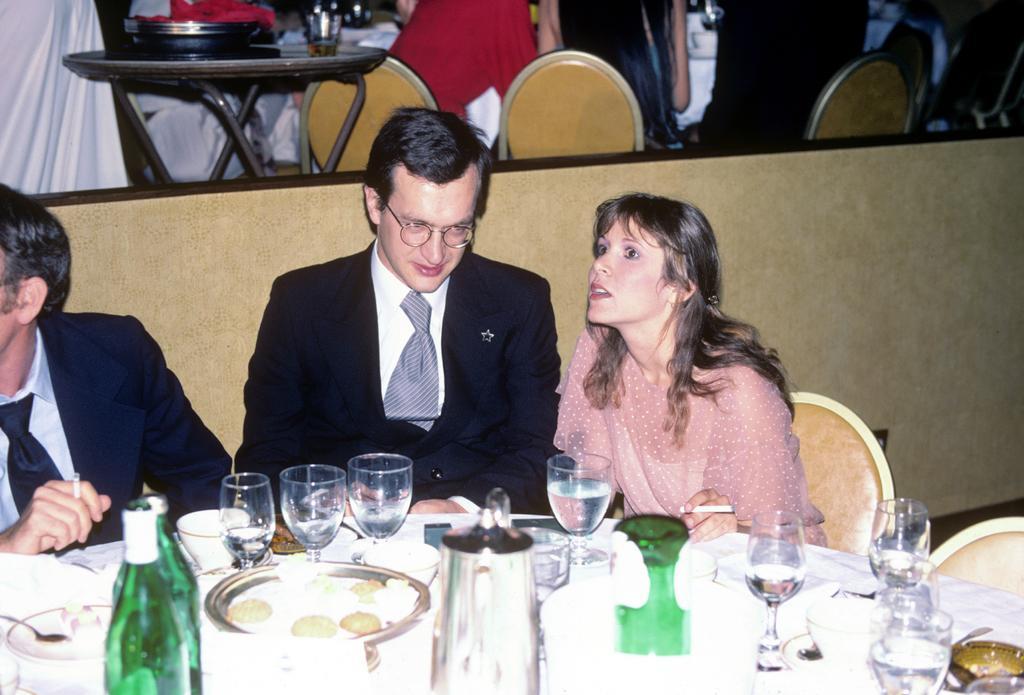In one or two sentences, can you explain what this image depicts? This is looking like a restaurant. Here I can see two men and a woman are sitting on the chairs in front of the table. On the table I can see few glasses, plates, bottles, spoons and some other objects. At the top of the image there are some more people, chairs and tables. 